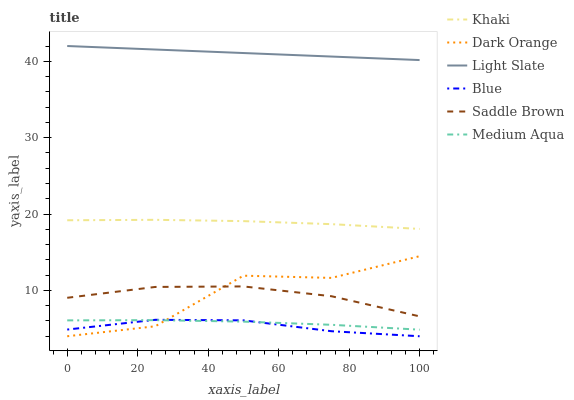Does Blue have the minimum area under the curve?
Answer yes or no. Yes. Does Light Slate have the maximum area under the curve?
Answer yes or no. Yes. Does Dark Orange have the minimum area under the curve?
Answer yes or no. No. Does Dark Orange have the maximum area under the curve?
Answer yes or no. No. Is Light Slate the smoothest?
Answer yes or no. Yes. Is Dark Orange the roughest?
Answer yes or no. Yes. Is Khaki the smoothest?
Answer yes or no. No. Is Khaki the roughest?
Answer yes or no. No. Does Khaki have the lowest value?
Answer yes or no. No. Does Dark Orange have the highest value?
Answer yes or no. No. Is Saddle Brown less than Light Slate?
Answer yes or no. Yes. Is Saddle Brown greater than Blue?
Answer yes or no. Yes. Does Saddle Brown intersect Light Slate?
Answer yes or no. No. 